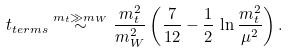Convert formula to latex. <formula><loc_0><loc_0><loc_500><loc_500>t _ { t e r m s } \stackrel { m _ { t } \gg m _ { W } } { \sim } \frac { m _ { t } ^ { 2 } } { m _ { W } ^ { 2 } } \left ( \frac { 7 } { 1 2 } - \frac { 1 } { 2 } \, \ln \frac { m _ { t } ^ { 2 } } { \mu ^ { 2 } } \right ) .</formula> 